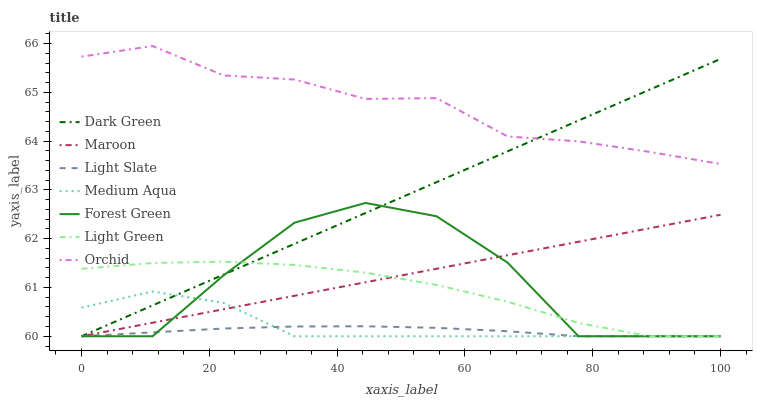Does Maroon have the minimum area under the curve?
Answer yes or no. No. Does Maroon have the maximum area under the curve?
Answer yes or no. No. Is Forest Green the smoothest?
Answer yes or no. No. Is Maroon the roughest?
Answer yes or no. No. Does Orchid have the lowest value?
Answer yes or no. No. Does Maroon have the highest value?
Answer yes or no. No. Is Light Slate less than Orchid?
Answer yes or no. Yes. Is Orchid greater than Medium Aqua?
Answer yes or no. Yes. Does Light Slate intersect Orchid?
Answer yes or no. No. 